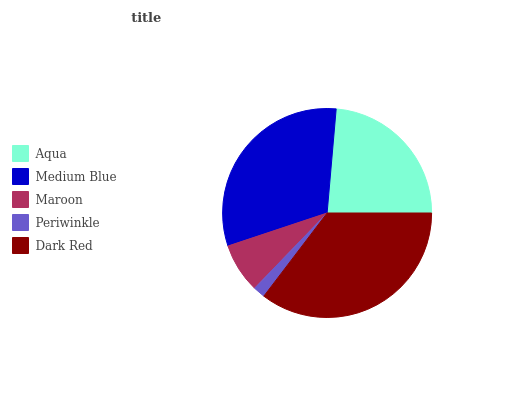Is Periwinkle the minimum?
Answer yes or no. Yes. Is Dark Red the maximum?
Answer yes or no. Yes. Is Medium Blue the minimum?
Answer yes or no. No. Is Medium Blue the maximum?
Answer yes or no. No. Is Medium Blue greater than Aqua?
Answer yes or no. Yes. Is Aqua less than Medium Blue?
Answer yes or no. Yes. Is Aqua greater than Medium Blue?
Answer yes or no. No. Is Medium Blue less than Aqua?
Answer yes or no. No. Is Aqua the high median?
Answer yes or no. Yes. Is Aqua the low median?
Answer yes or no. Yes. Is Medium Blue the high median?
Answer yes or no. No. Is Periwinkle the low median?
Answer yes or no. No. 